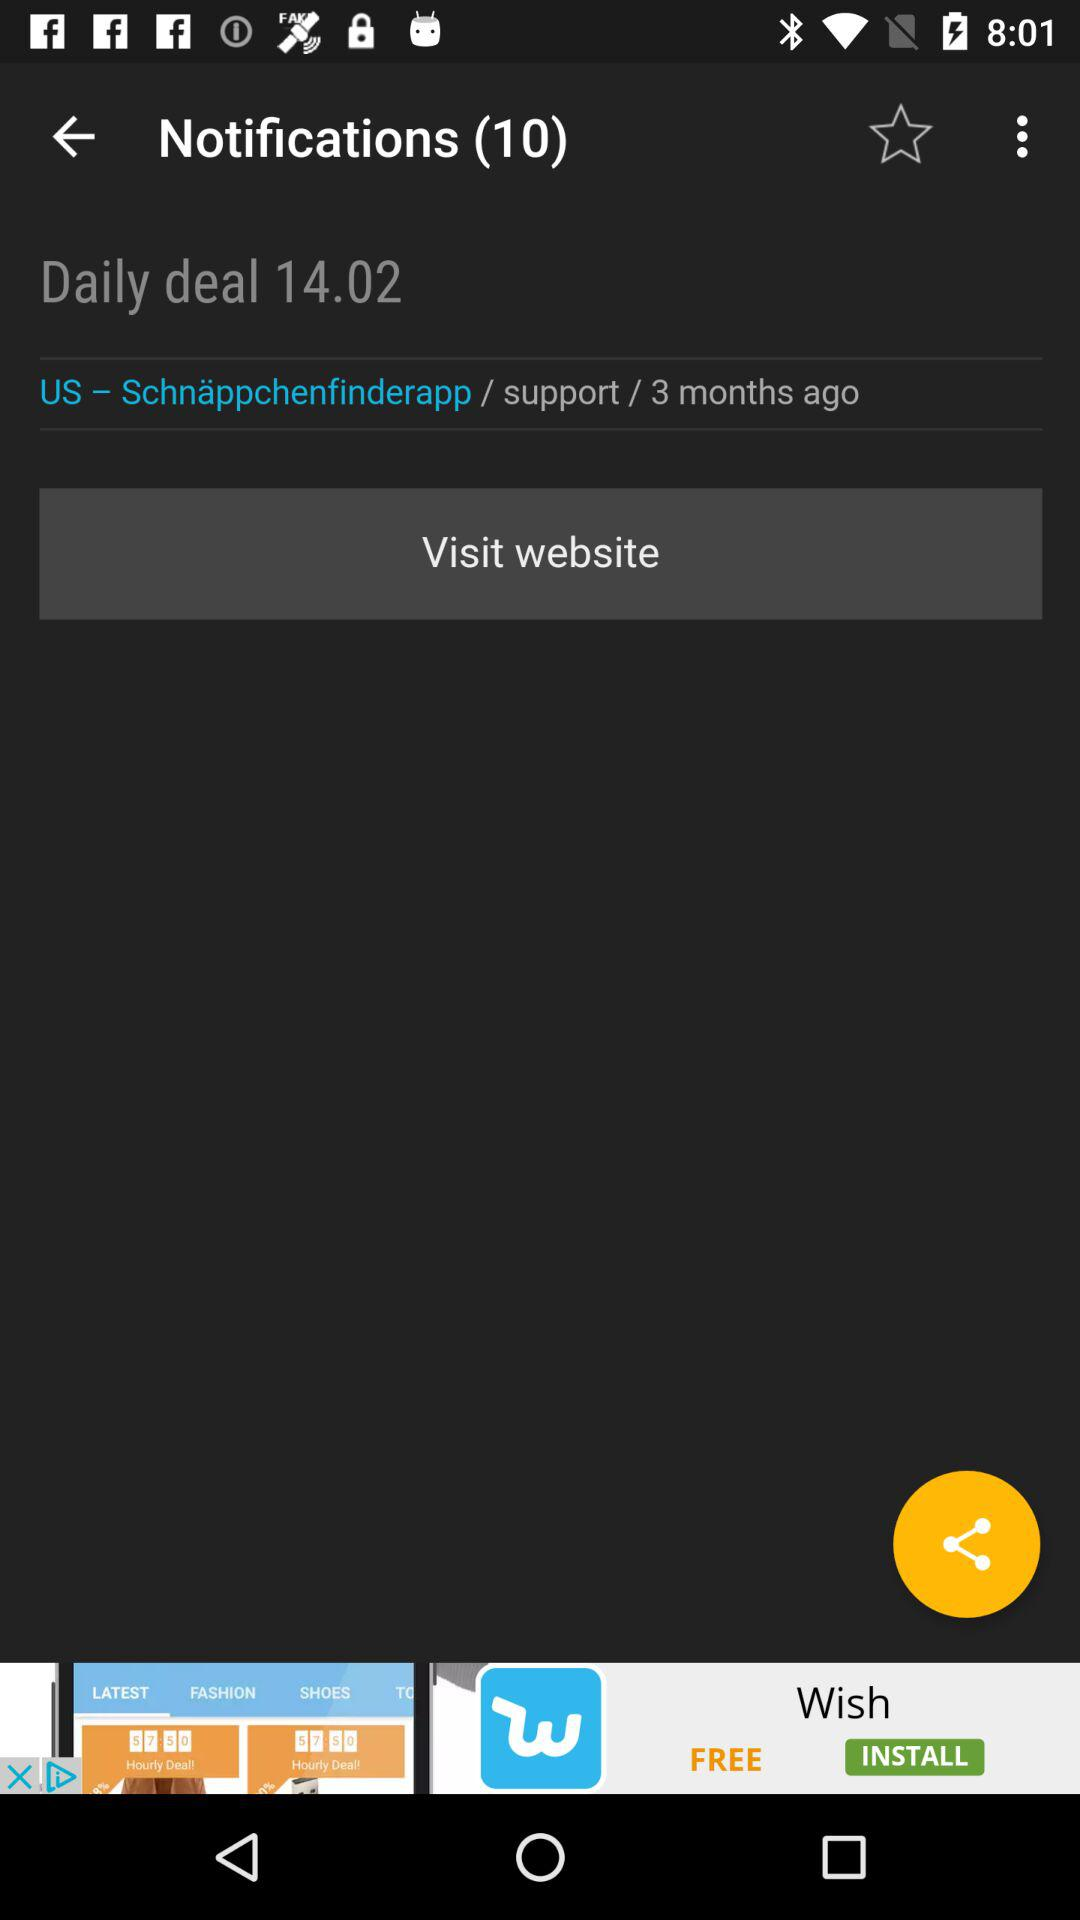When did the "Daily deal" started? The "Daily deal" was started on February 14. 